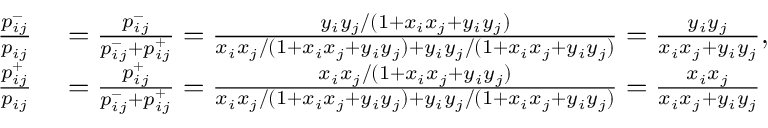Convert formula to latex. <formula><loc_0><loc_0><loc_500><loc_500>\begin{array} { r l } { \frac { p _ { i j } ^ { - } } { p _ { i j } } } & = \frac { p _ { i j } ^ { - } } { p _ { i j } ^ { - } + p _ { i j } ^ { + } } = \frac { y _ { i } y _ { j } / ( 1 + x _ { i } x _ { j } + y _ { i } y _ { j } ) } { x _ { i } x _ { j } / ( 1 + x _ { i } x _ { j } + y _ { i } y _ { j } ) + y _ { i } y _ { j } / ( 1 + x _ { i } x _ { j } + y _ { i } y _ { j } ) } = \frac { y _ { i } y _ { j } } { x _ { i } x _ { j } + y _ { i } y _ { j } } , } \\ { \frac { p _ { i j } ^ { + } } { p _ { i j } } } & = \frac { p _ { i j } ^ { + } } { p _ { i j } ^ { - } + p _ { i j } ^ { + } } = \frac { x _ { i } x _ { j } / ( 1 + x _ { i } x _ { j } + y _ { i } y _ { j } ) } { x _ { i } x _ { j } / ( 1 + x _ { i } x _ { j } + y _ { i } y _ { j } ) + y _ { i } y _ { j } / ( 1 + x _ { i } x _ { j } + y _ { i } y _ { j } ) } = \frac { x _ { i } x _ { j } } { x _ { i } x _ { j } + y _ { i } y _ { j } } } \end{array}</formula> 